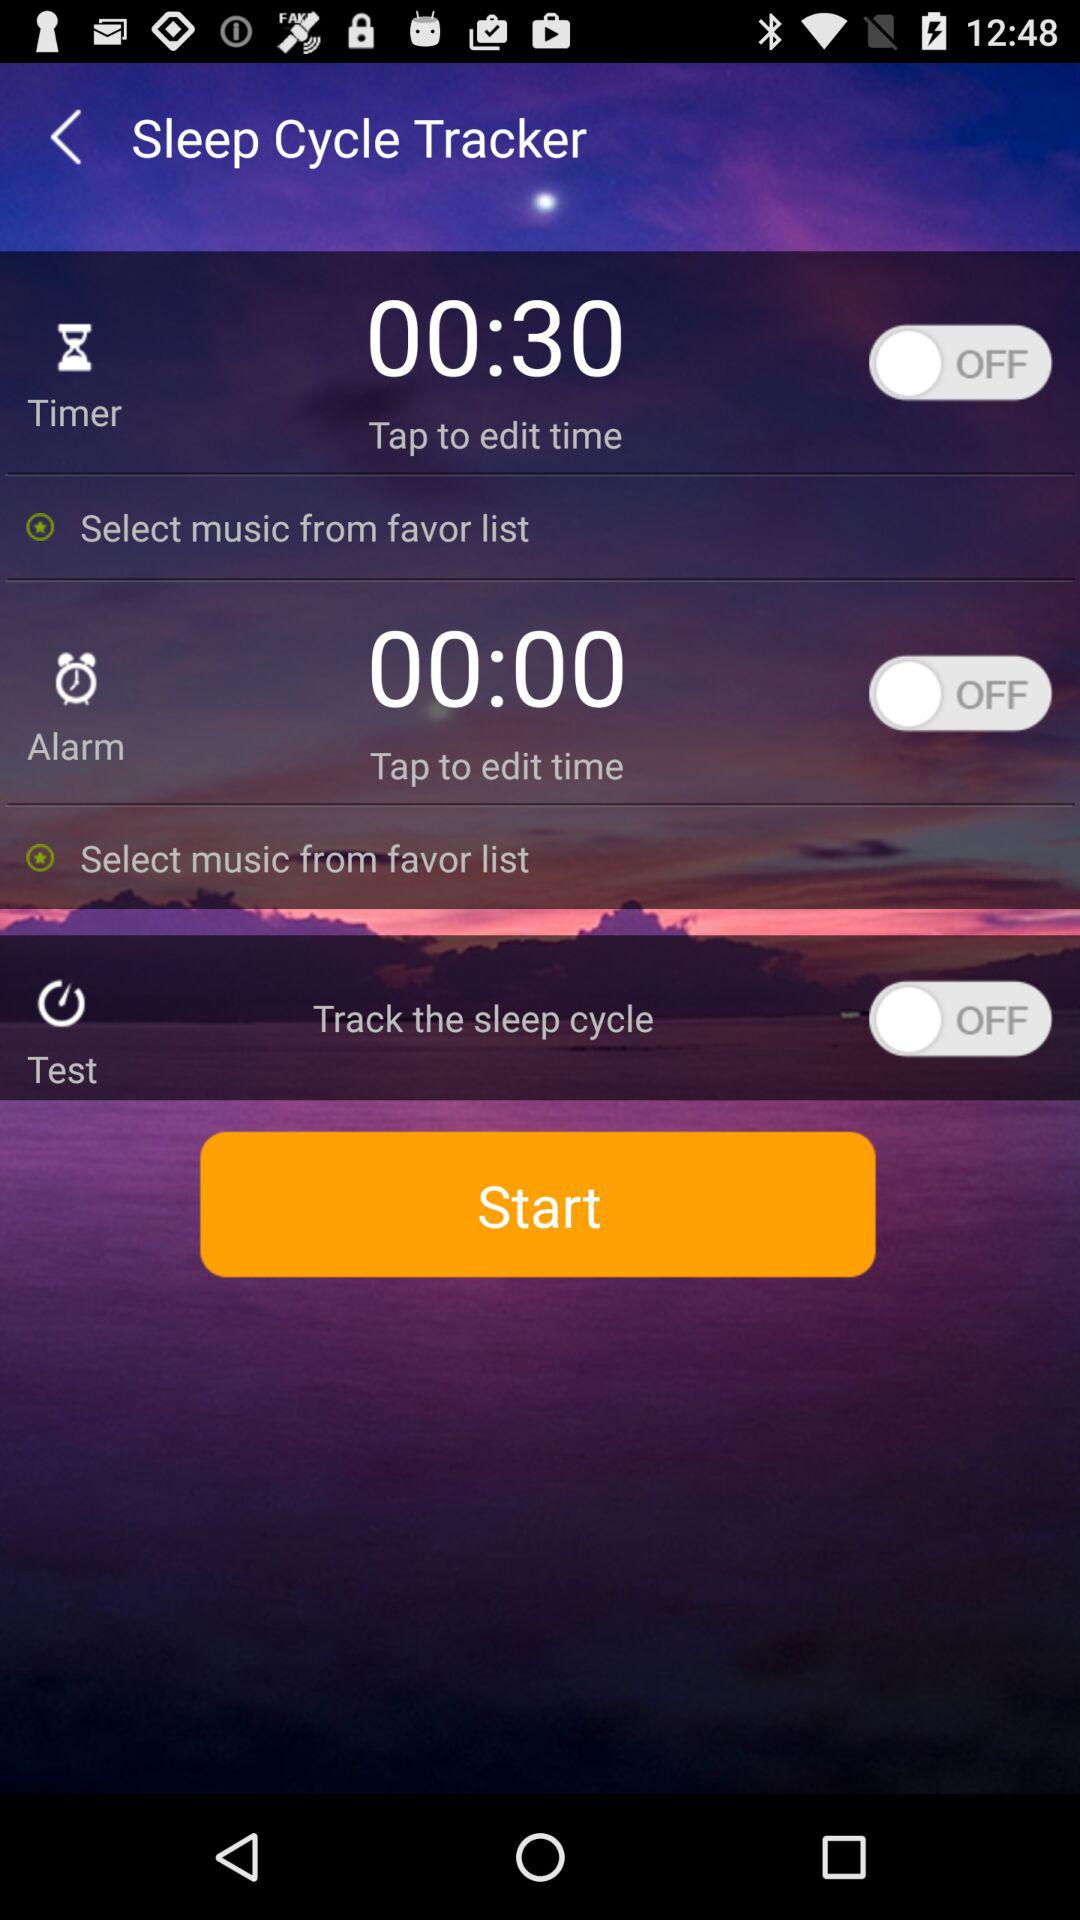What is the current status of the timer? The status is off. 